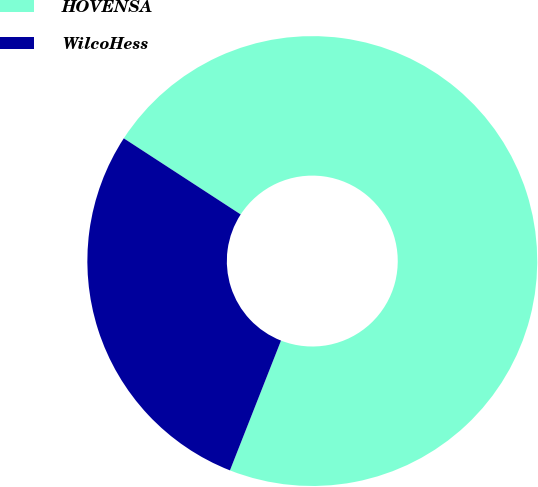Convert chart. <chart><loc_0><loc_0><loc_500><loc_500><pie_chart><fcel>HOVENSA<fcel>WilcoHess<nl><fcel>71.78%<fcel>28.22%<nl></chart> 